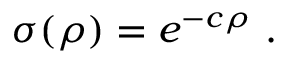<formula> <loc_0><loc_0><loc_500><loc_500>\sigma ( \rho ) = e ^ { - c \rho } .</formula> 